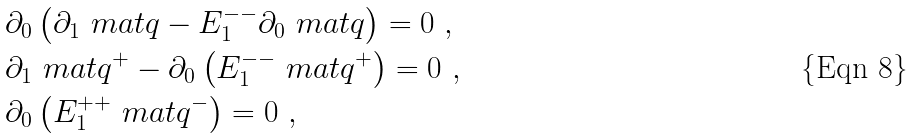<formula> <loc_0><loc_0><loc_500><loc_500>& \partial _ { 0 } \left ( \partial _ { 1 } \ m a t q - E _ { 1 } ^ { - - } \partial _ { 0 } \ m a t q \right ) = 0 \ , \\ & \partial _ { 1 } \ m a t q ^ { + } - \partial _ { 0 } \left ( E _ { 1 } ^ { - - } \ m a t q ^ { + } \right ) = 0 \ , \\ & \partial _ { 0 } \left ( E _ { 1 } ^ { + + } \ m a t q ^ { - } \right ) = 0 \ ,</formula> 